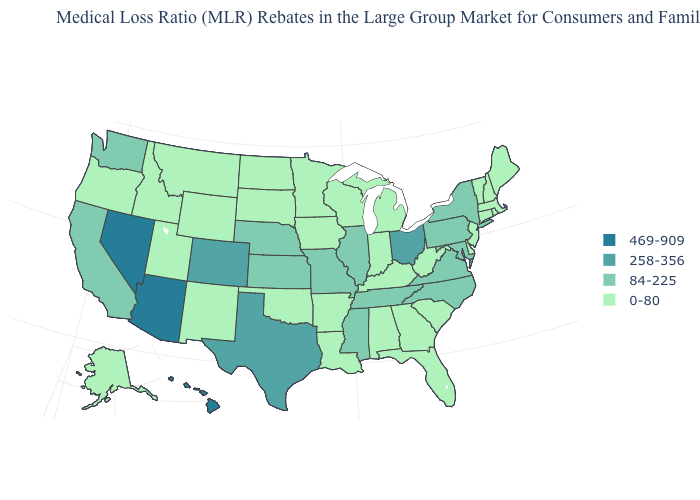Which states have the highest value in the USA?
Write a very short answer. Arizona, Hawaii, Nevada. What is the value of Rhode Island?
Keep it brief. 0-80. What is the value of Colorado?
Keep it brief. 258-356. Name the states that have a value in the range 469-909?
Quick response, please. Arizona, Hawaii, Nevada. What is the value of Arkansas?
Be succinct. 0-80. Does the map have missing data?
Give a very brief answer. No. What is the value of North Carolina?
Keep it brief. 84-225. What is the highest value in the Northeast ?
Short answer required. 84-225. Which states have the lowest value in the USA?
Give a very brief answer. Alabama, Alaska, Arkansas, Connecticut, Delaware, Florida, Georgia, Idaho, Indiana, Iowa, Kentucky, Louisiana, Maine, Massachusetts, Michigan, Minnesota, Montana, New Hampshire, New Jersey, New Mexico, North Dakota, Oklahoma, Oregon, Rhode Island, South Carolina, South Dakota, Utah, Vermont, West Virginia, Wisconsin, Wyoming. Name the states that have a value in the range 0-80?
Short answer required. Alabama, Alaska, Arkansas, Connecticut, Delaware, Florida, Georgia, Idaho, Indiana, Iowa, Kentucky, Louisiana, Maine, Massachusetts, Michigan, Minnesota, Montana, New Hampshire, New Jersey, New Mexico, North Dakota, Oklahoma, Oregon, Rhode Island, South Carolina, South Dakota, Utah, Vermont, West Virginia, Wisconsin, Wyoming. How many symbols are there in the legend?
Be succinct. 4. Does Washington have a higher value than Wyoming?
Write a very short answer. Yes. Does Kansas have the lowest value in the MidWest?
Write a very short answer. No. Among the states that border California , does Arizona have the lowest value?
Write a very short answer. No. What is the value of Kentucky?
Be succinct. 0-80. 